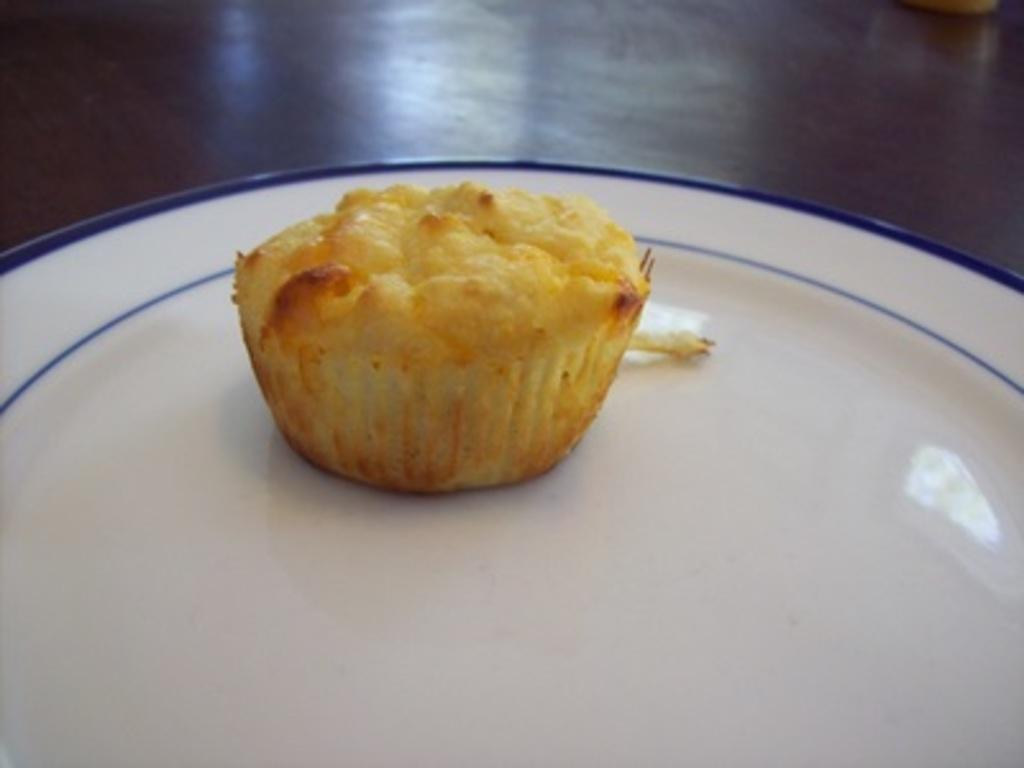What type of dessert is visible in the image? There is a cupcake in the image. Where is the cupcake placed? The cupcake is on a platter. What is the platter resting on? The platter is on a wooden surface. What color is the scarf wrapped around the cupcake in the image? There is no scarf present in the image; the cupcake is simply on a platter. 